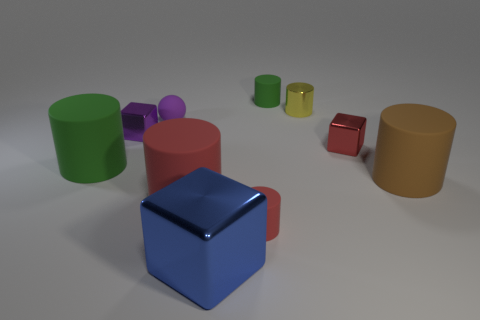What number of big blue things are there?
Your response must be concise. 1. The small matte thing on the left side of the small matte cylinder that is in front of the brown cylinder is what color?
Keep it short and to the point. Purple. There is a metallic thing that is the same size as the brown rubber object; what color is it?
Your answer should be compact. Blue. Are there any metallic things of the same color as the metal cylinder?
Make the answer very short. No. Are there any large blue rubber cubes?
Ensure brevity in your answer.  No. There is a tiny matte thing that is in front of the purple shiny thing; what is its shape?
Your answer should be compact. Cylinder. How many rubber things are in front of the purple ball and to the left of the large red matte object?
Provide a short and direct response. 1. What number of other objects are there of the same size as the blue block?
Offer a terse response. 3. Does the yellow shiny object on the right side of the tiny green rubber cylinder have the same shape as the big matte thing on the left side of the purple rubber sphere?
Your answer should be compact. Yes. How many things are either tiny green things or things that are on the right side of the large green thing?
Ensure brevity in your answer.  9. 